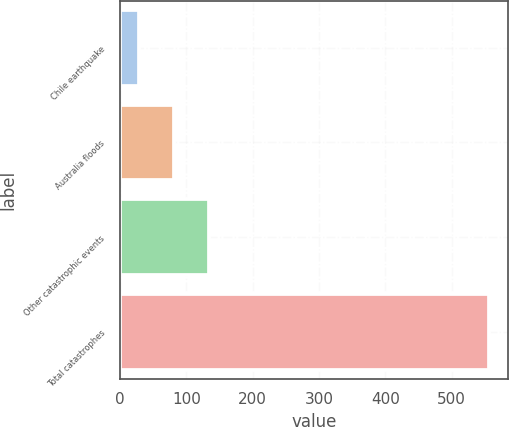<chart> <loc_0><loc_0><loc_500><loc_500><bar_chart><fcel>Chile earthquake<fcel>Australia floods<fcel>Other catastrophic events<fcel>Total catastrophes<nl><fcel>28<fcel>80.9<fcel>133.8<fcel>557<nl></chart> 